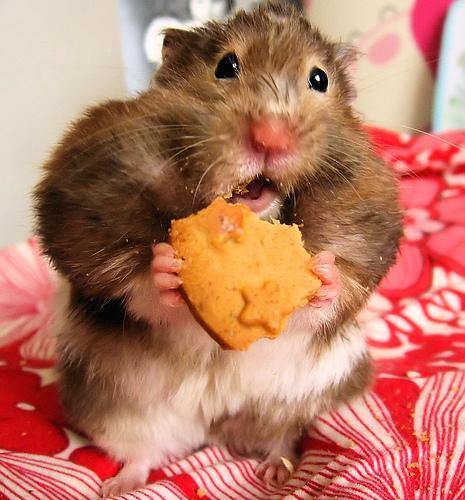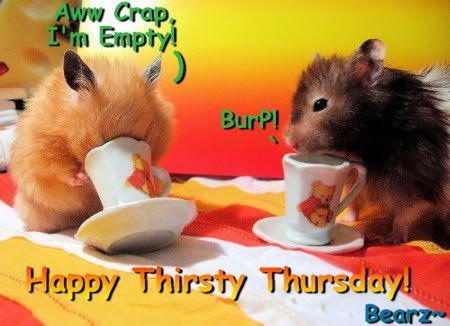The first image is the image on the left, the second image is the image on the right. Evaluate the accuracy of this statement regarding the images: "An image includes an upright hamster grasping a piece of food nearly as big as its head.". Is it true? Answer yes or no. Yes. The first image is the image on the left, the second image is the image on the right. Analyze the images presented: Is the assertion "A hamster in the right image is eating something." valid? Answer yes or no. No. 